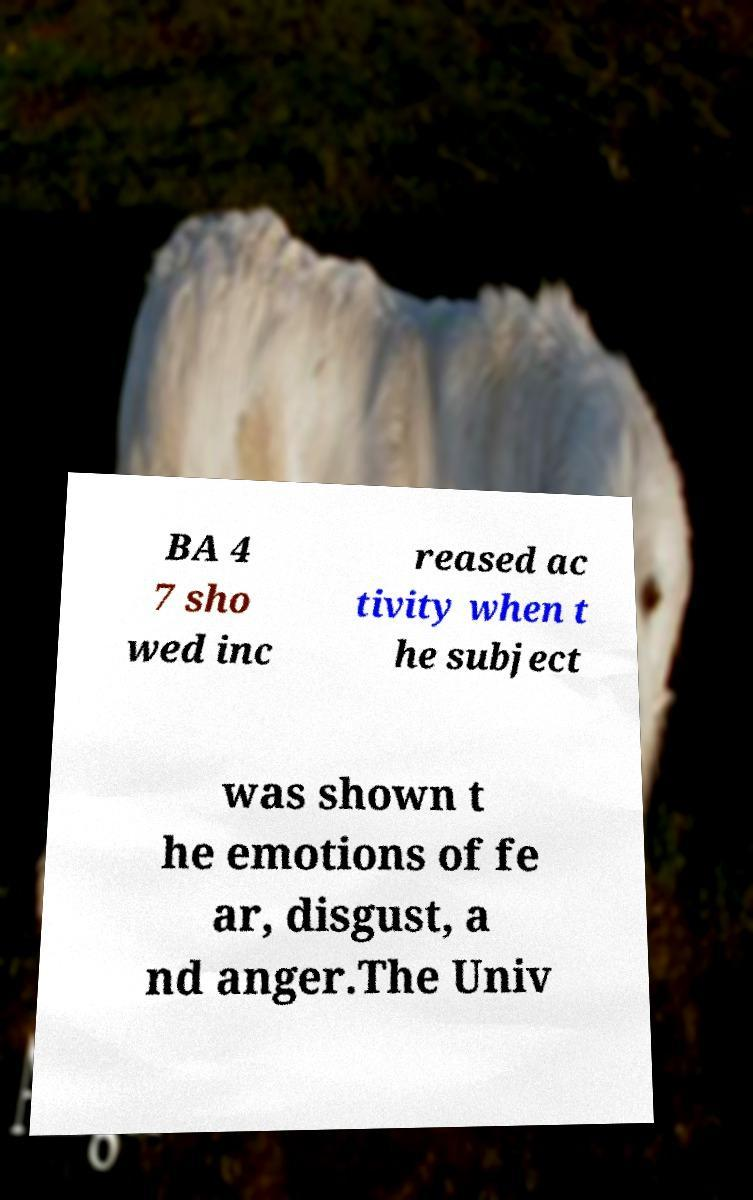Could you assist in decoding the text presented in this image and type it out clearly? BA 4 7 sho wed inc reased ac tivity when t he subject was shown t he emotions of fe ar, disgust, a nd anger.The Univ 